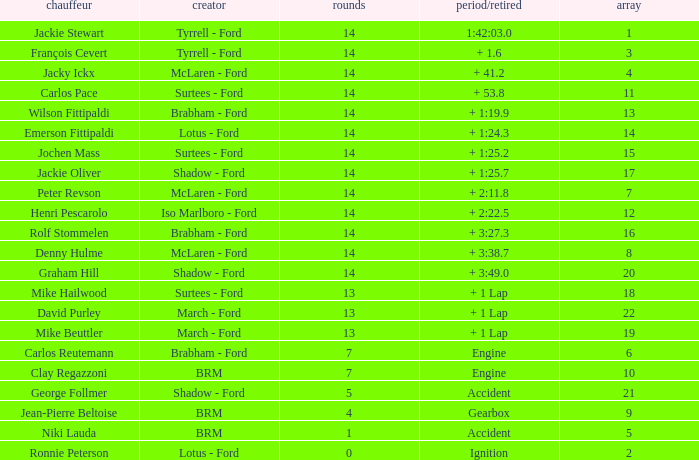What grad has a Time/Retired of + 1:24.3? 14.0. 